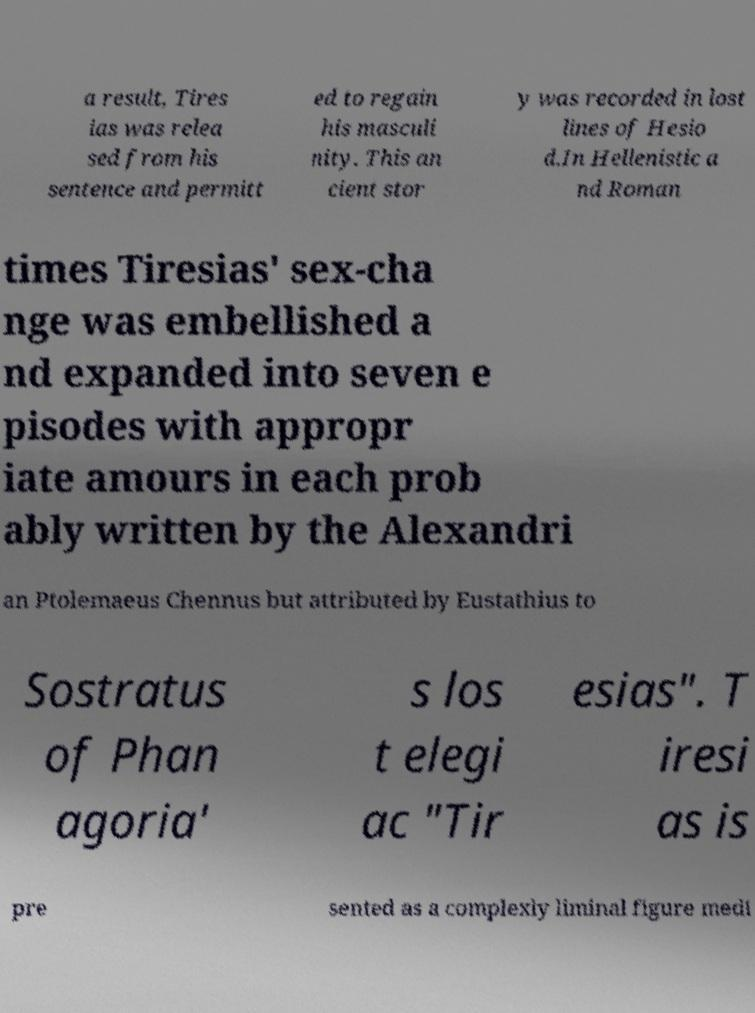Could you extract and type out the text from this image? a result, Tires ias was relea sed from his sentence and permitt ed to regain his masculi nity. This an cient stor y was recorded in lost lines of Hesio d.In Hellenistic a nd Roman times Tiresias' sex-cha nge was embellished a nd expanded into seven e pisodes with appropr iate amours in each prob ably written by the Alexandri an Ptolemaeus Chennus but attributed by Eustathius to Sostratus of Phan agoria' s los t elegi ac "Tir esias". T iresi as is pre sented as a complexly liminal figure medi 